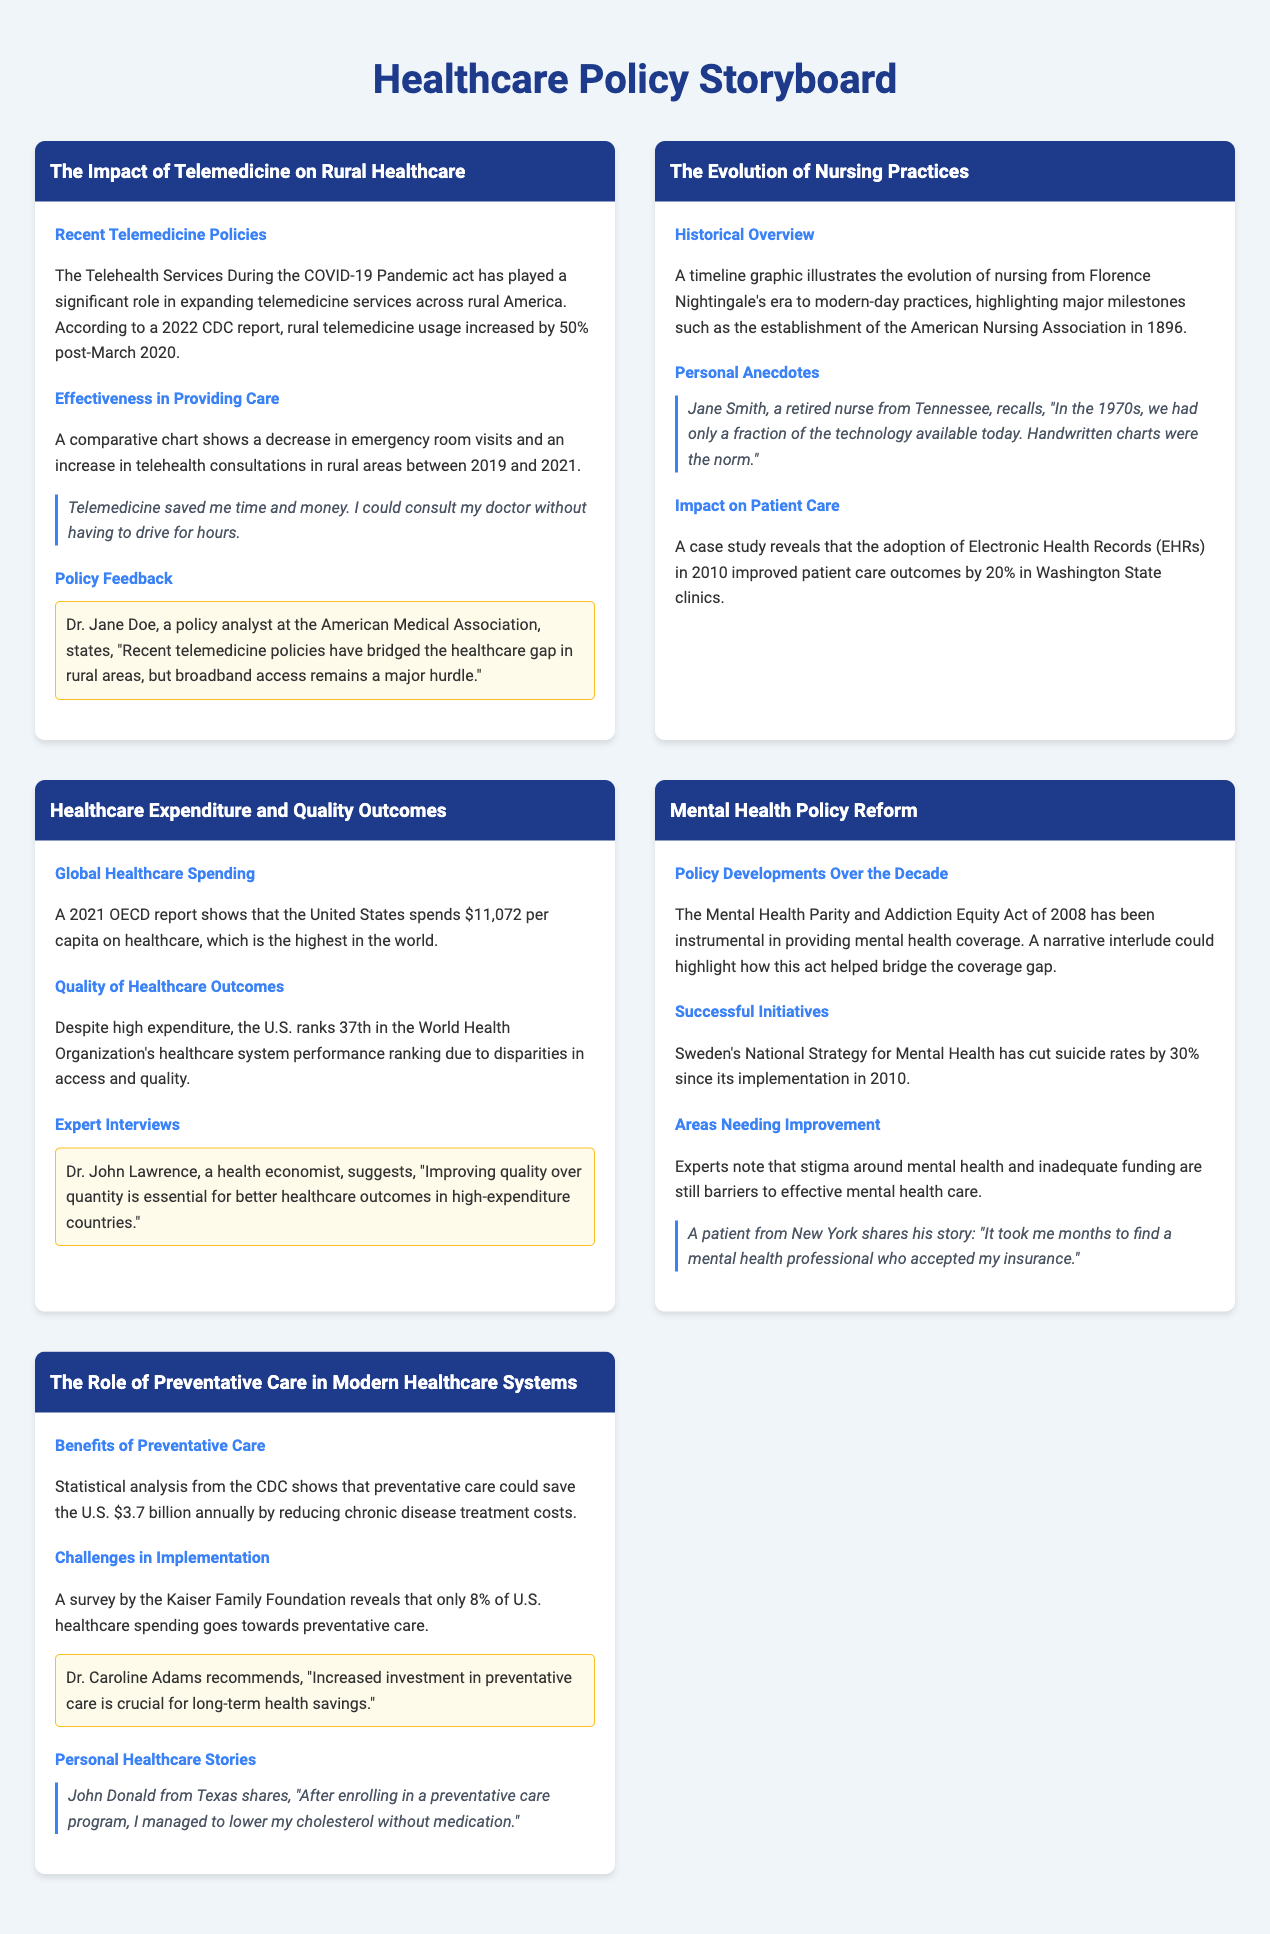What was the increase in rural telemedicine usage post-March 2020? The document states that rural telemedicine usage increased by 50% after March 2020.
Answer: 50% Who is the retired nurse that shared her personal anecdote about nursing practices? The document mentions Jane Smith as the retired nurse from Tennessee.
Answer: Jane Smith What year was the American Nursing Association established? The historical overview highlights the establishment of the American Nursing Association in 1896.
Answer: 1896 What country is noted for spending the highest per capita on healthcare? The document indicates that the United States is the highest in per capita healthcare spending.
Answer: United States What is the estimated annual savings from preventative care according to the CDC? Statistical analysis from the CDC suggests that preventative care could save the U.S. $3.7 billion annually.
Answer: $3.7 billion Which act helped bridge the coverage gap in mental health? The document refers to the Mental Health Parity and Addiction Equity Act of 2008 as a significant policy development.
Answer: Mental Health Parity and Addiction Equity Act of 2008 What percentage of U.S. healthcare spending is currently allocated to preventative care? A survey reveals that only 8% of U.S. healthcare spending goes towards preventative care.
Answer: 8% What major hurdle remains for telemedicine in rural areas? The document notes that broadband access remains a major hurdle for telemedicine in rural areas.
Answer: Broadband access How much did Sweden's National Strategy for Mental Health reduce suicide rates? The document states that it has cut suicide rates by 30% since its implementation in 2010.
Answer: 30% 